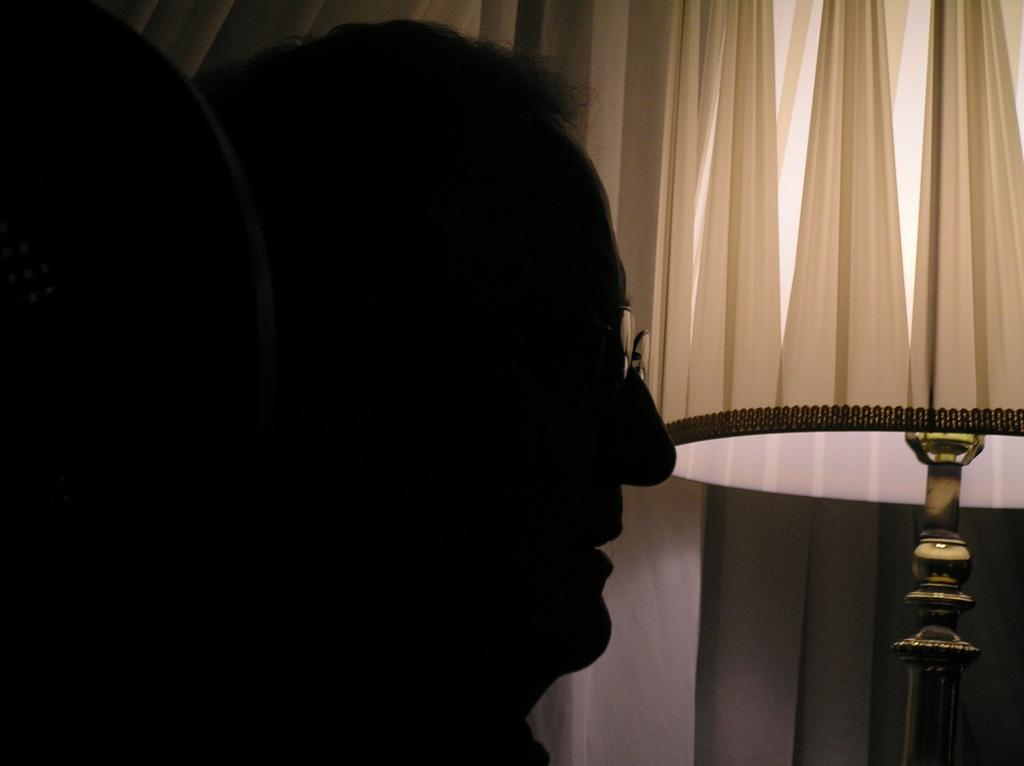Where was the image taken? The image was taken in a room. Can you describe the lighting in the room? The room is dark. What is the main subject in the foreground of the image? There is a person in the foreground of the image. What object can be seen on the right side of the image? There is a lamp on the right side of the image. What color is the curtain visible in the background of the image? There is a white-colored curtain in the background of the image. What type of instrument does the person in the image need to play? There is no instrument present in the image, so it is not possible to determine what instrument the person might need. 